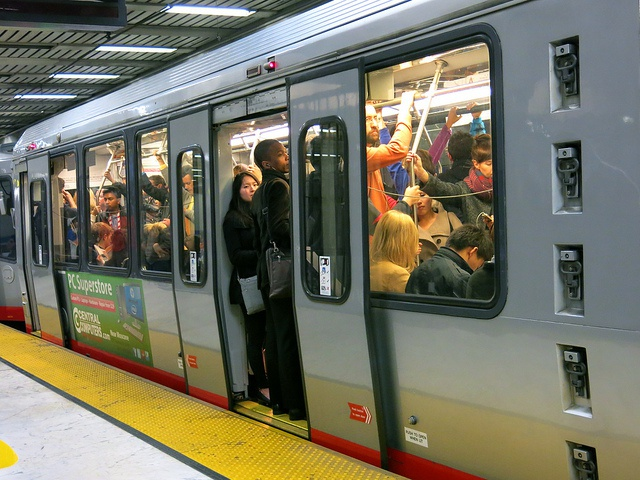Describe the objects in this image and their specific colors. I can see train in black, gray, and darkgray tones, people in black, gray, darkgreen, and brown tones, people in black, maroon, and gray tones, people in black, gray, brown, and tan tones, and people in black, gray, and darkgreen tones in this image. 